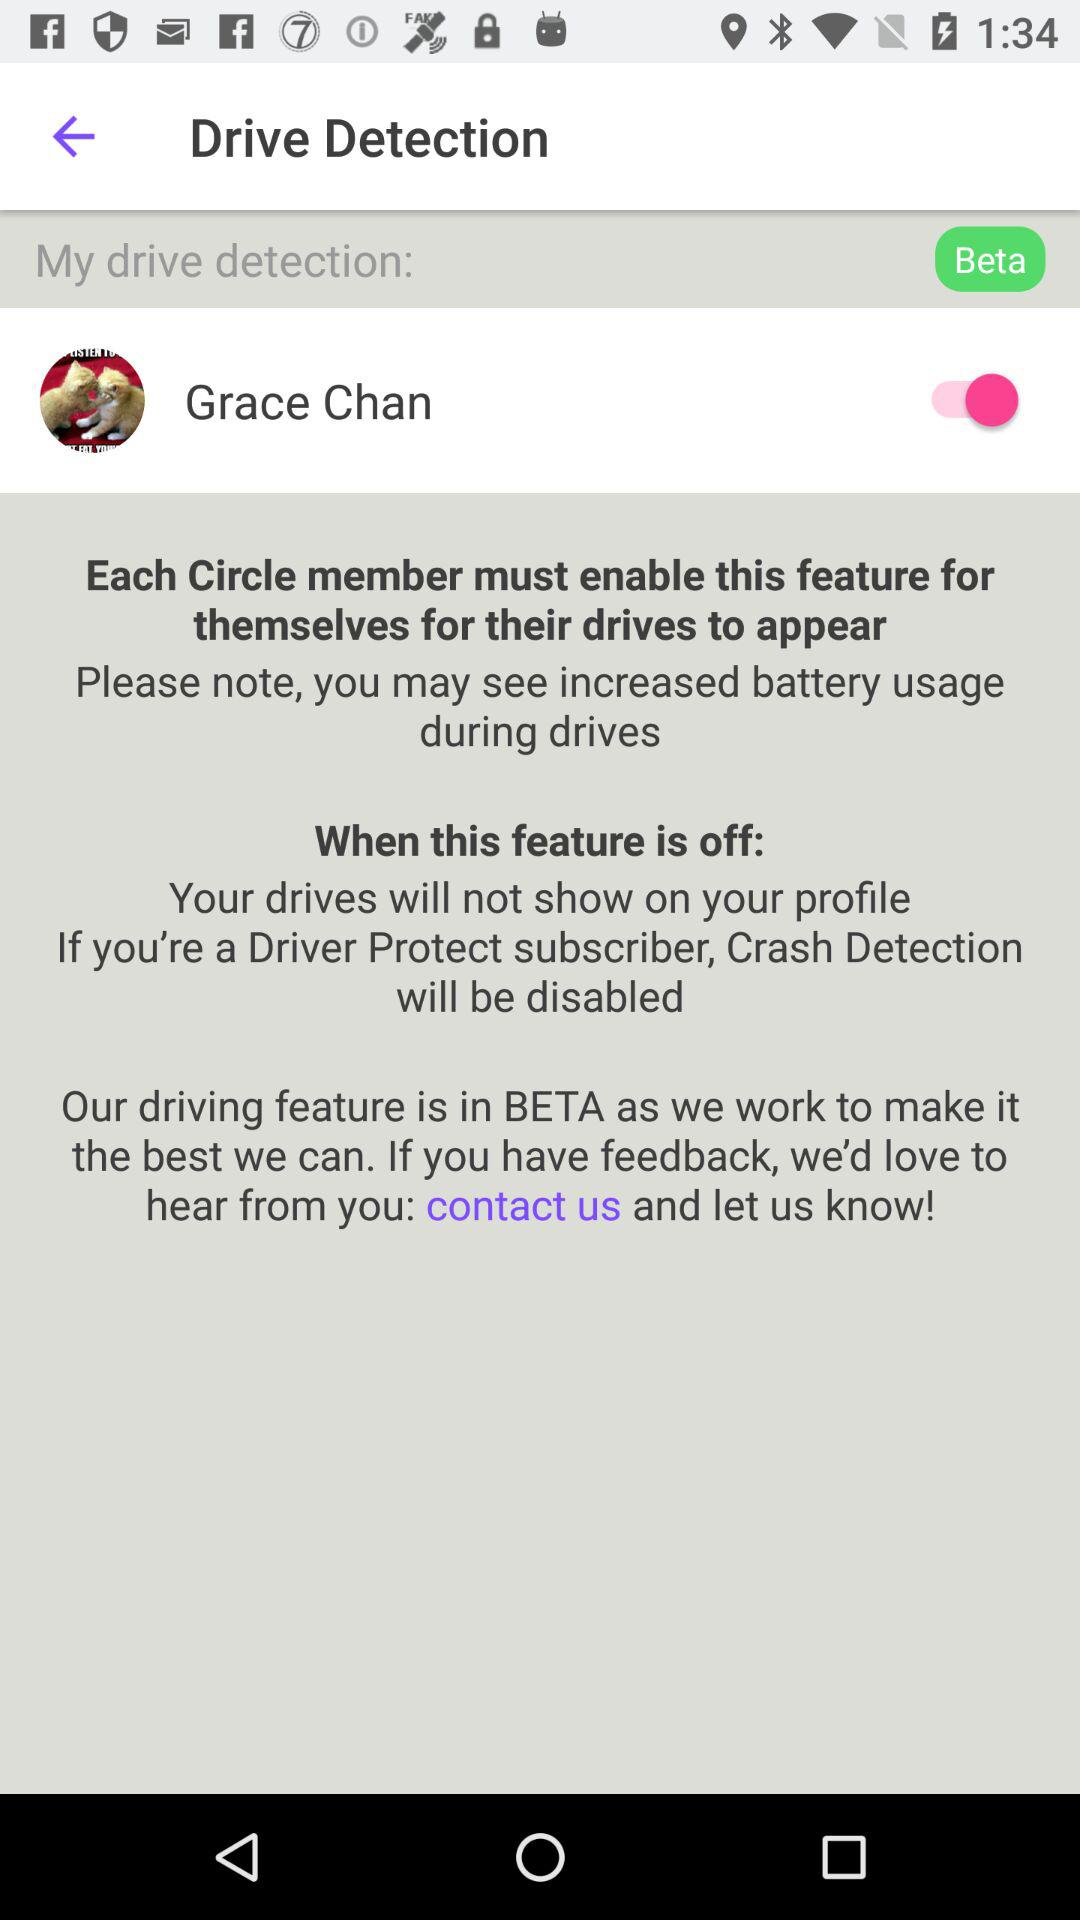Which is the drive detector?
When the provided information is insufficient, respond with <no answer>. <no answer> 